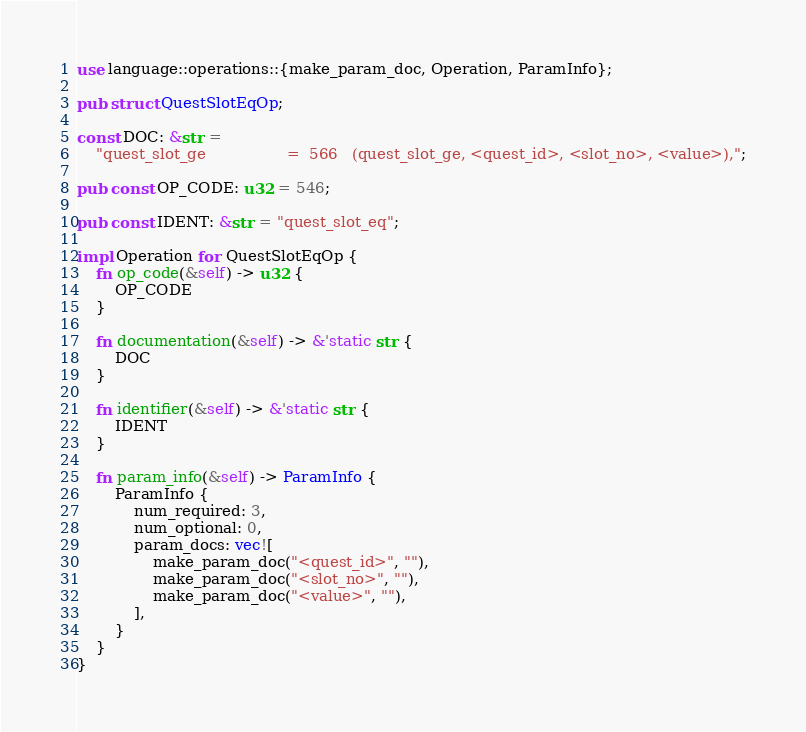Convert code to text. <code><loc_0><loc_0><loc_500><loc_500><_Rust_>use language::operations::{make_param_doc, Operation, ParamInfo};

pub struct QuestSlotEqOp;

const DOC: &str =
    "quest_slot_ge                 =  566   (quest_slot_ge, <quest_id>, <slot_no>, <value>),";

pub const OP_CODE: u32 = 546;

pub const IDENT: &str = "quest_slot_eq";

impl Operation for QuestSlotEqOp {
    fn op_code(&self) -> u32 {
        OP_CODE
    }

    fn documentation(&self) -> &'static str {
        DOC
    }

    fn identifier(&self) -> &'static str {
        IDENT
    }

    fn param_info(&self) -> ParamInfo {
        ParamInfo {
            num_required: 3,
            num_optional: 0,
            param_docs: vec![
                make_param_doc("<quest_id>", ""),
                make_param_doc("<slot_no>", ""),
                make_param_doc("<value>", ""),
            ],
        }
    }
}
</code> 